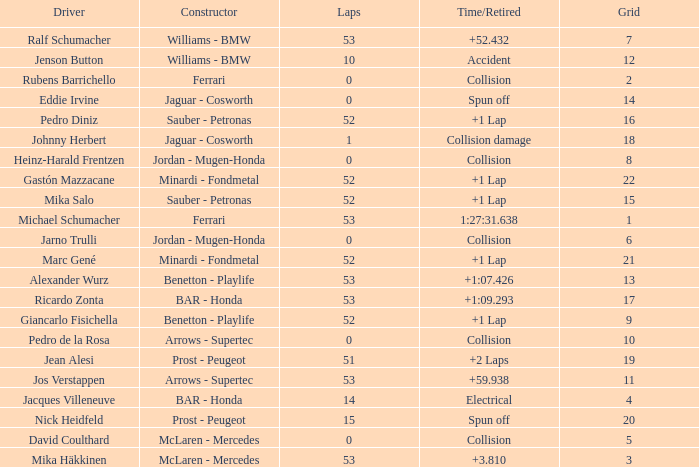How many laps did Ricardo Zonta have? 53.0. 